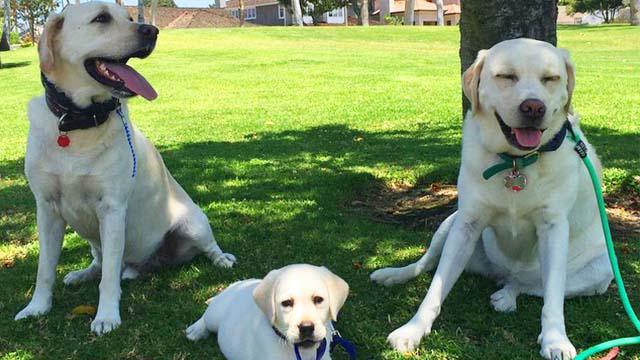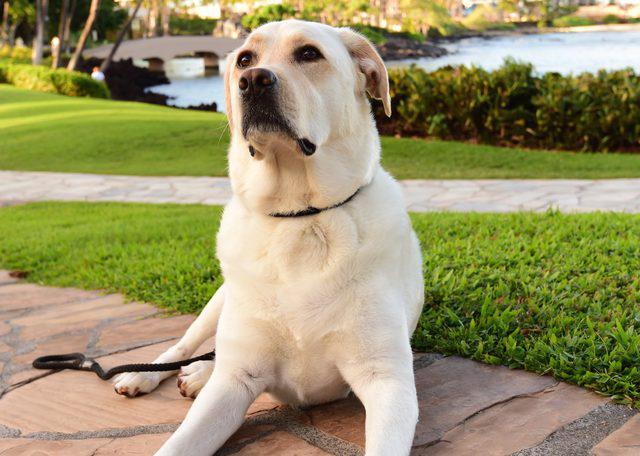The first image is the image on the left, the second image is the image on the right. Assess this claim about the two images: "There is at least one dog wearing a leash". Correct or not? Answer yes or no. Yes. The first image is the image on the left, the second image is the image on the right. Analyze the images presented: Is the assertion "The left image includes a royal blue leash and an adult white dog sitting upright on green grass." valid? Answer yes or no. Yes. 